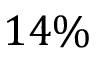<formula> <loc_0><loc_0><loc_500><loc_500>1 4 \%</formula> 